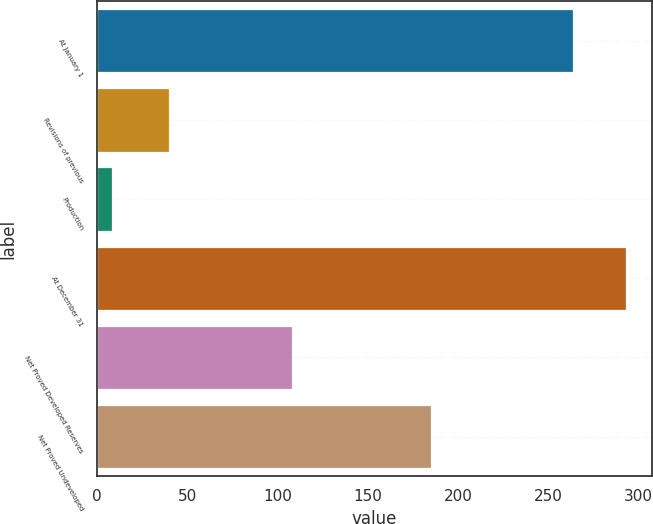Convert chart to OTSL. <chart><loc_0><loc_0><loc_500><loc_500><bar_chart><fcel>At January 1<fcel>Revisions of previous<fcel>Production<fcel>At December 31<fcel>Net Proved Developed Reserves<fcel>Net Proved Undeveloped<nl><fcel>264<fcel>40<fcel>8<fcel>293<fcel>108<fcel>185<nl></chart> 